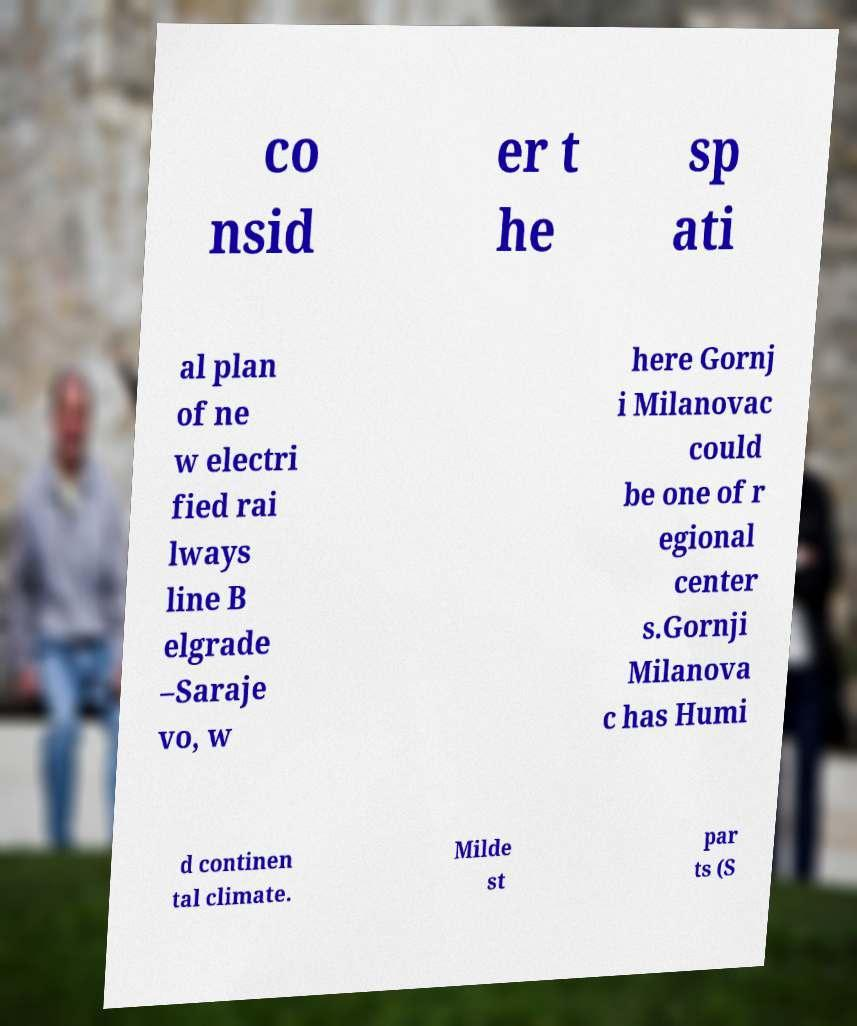Could you extract and type out the text from this image? co nsid er t he sp ati al plan of ne w electri fied rai lways line B elgrade –Saraje vo, w here Gornj i Milanovac could be one of r egional center s.Gornji Milanova c has Humi d continen tal climate. Milde st par ts (S 